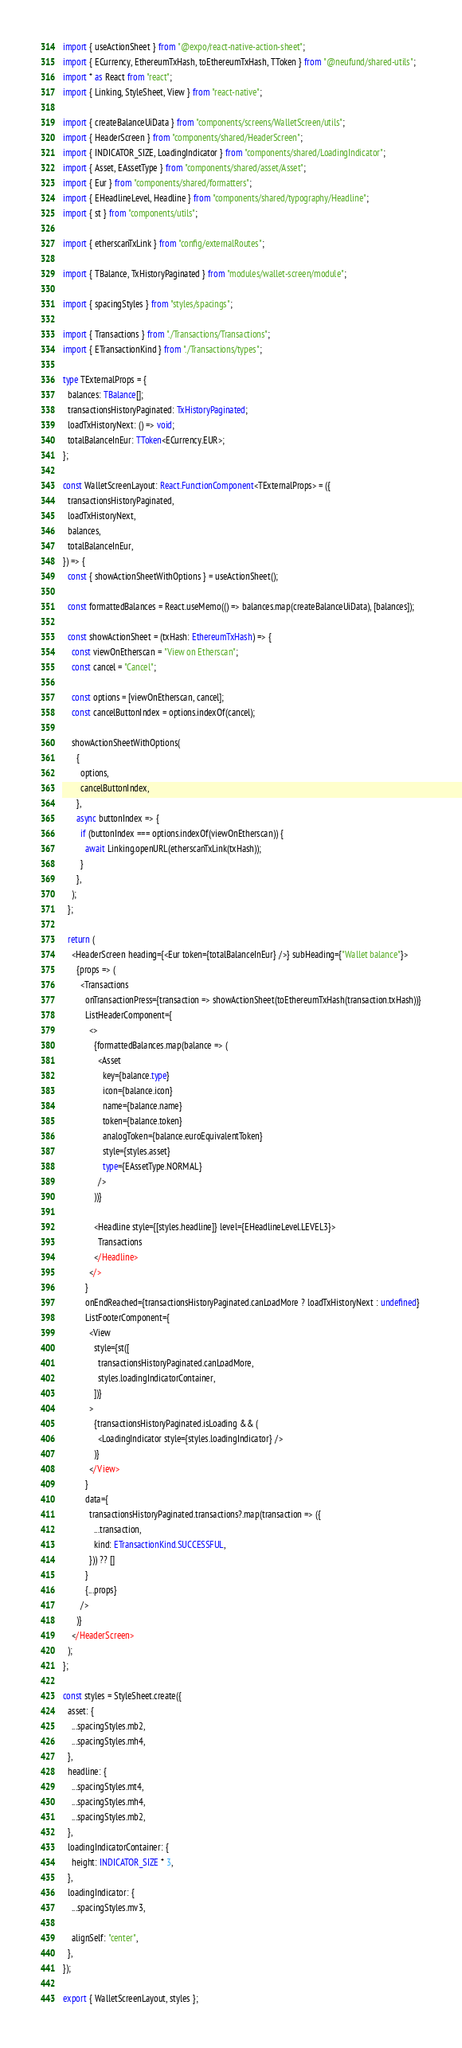Convert code to text. <code><loc_0><loc_0><loc_500><loc_500><_TypeScript_>import { useActionSheet } from "@expo/react-native-action-sheet";
import { ECurrency, EthereumTxHash, toEthereumTxHash, TToken } from "@neufund/shared-utils";
import * as React from "react";
import { Linking, StyleSheet, View } from "react-native";

import { createBalanceUiData } from "components/screens/WalletScreen/utils";
import { HeaderScreen } from "components/shared/HeaderScreen";
import { INDICATOR_SIZE, LoadingIndicator } from "components/shared/LoadingIndicator";
import { Asset, EAssetType } from "components/shared/asset/Asset";
import { Eur } from "components/shared/formatters";
import { EHeadlineLevel, Headline } from "components/shared/typography/Headline";
import { st } from "components/utils";

import { etherscanTxLink } from "config/externalRoutes";

import { TBalance, TxHistoryPaginated } from "modules/wallet-screen/module";

import { spacingStyles } from "styles/spacings";

import { Transactions } from "./Transactions/Transactions";
import { ETransactionKind } from "./Transactions/types";

type TExternalProps = {
  balances: TBalance[];
  transactionsHistoryPaginated: TxHistoryPaginated;
  loadTxHistoryNext: () => void;
  totalBalanceInEur: TToken<ECurrency.EUR>;
};

const WalletScreenLayout: React.FunctionComponent<TExternalProps> = ({
  transactionsHistoryPaginated,
  loadTxHistoryNext,
  balances,
  totalBalanceInEur,
}) => {
  const { showActionSheetWithOptions } = useActionSheet();

  const formattedBalances = React.useMemo(() => balances.map(createBalanceUiData), [balances]);

  const showActionSheet = (txHash: EthereumTxHash) => {
    const viewOnEtherscan = "View on Etherscan";
    const cancel = "Cancel";

    const options = [viewOnEtherscan, cancel];
    const cancelButtonIndex = options.indexOf(cancel);

    showActionSheetWithOptions(
      {
        options,
        cancelButtonIndex,
      },
      async buttonIndex => {
        if (buttonIndex === options.indexOf(viewOnEtherscan)) {
          await Linking.openURL(etherscanTxLink(txHash));
        }
      },
    );
  };

  return (
    <HeaderScreen heading={<Eur token={totalBalanceInEur} />} subHeading={"Wallet balance"}>
      {props => (
        <Transactions
          onTransactionPress={transaction => showActionSheet(toEthereumTxHash(transaction.txHash))}
          ListHeaderComponent={
            <>
              {formattedBalances.map(balance => (
                <Asset
                  key={balance.type}
                  icon={balance.icon}
                  name={balance.name}
                  token={balance.token}
                  analogToken={balance.euroEquivalentToken}
                  style={styles.asset}
                  type={EAssetType.NORMAL}
                />
              ))}

              <Headline style={[styles.headline]} level={EHeadlineLevel.LEVEL3}>
                Transactions
              </Headline>
            </>
          }
          onEndReached={transactionsHistoryPaginated.canLoadMore ? loadTxHistoryNext : undefined}
          ListFooterComponent={
            <View
              style={st([
                transactionsHistoryPaginated.canLoadMore,
                styles.loadingIndicatorContainer,
              ])}
            >
              {transactionsHistoryPaginated.isLoading && (
                <LoadingIndicator style={styles.loadingIndicator} />
              )}
            </View>
          }
          data={
            transactionsHistoryPaginated.transactions?.map(transaction => ({
              ...transaction,
              kind: ETransactionKind.SUCCESSFUL,
            })) ?? []
          }
          {...props}
        />
      )}
    </HeaderScreen>
  );
};

const styles = StyleSheet.create({
  asset: {
    ...spacingStyles.mb2,
    ...spacingStyles.mh4,
  },
  headline: {
    ...spacingStyles.mt4,
    ...spacingStyles.mh4,
    ...spacingStyles.mb2,
  },
  loadingIndicatorContainer: {
    height: INDICATOR_SIZE * 3,
  },
  loadingIndicator: {
    ...spacingStyles.mv3,

    alignSelf: "center",
  },
});

export { WalletScreenLayout, styles };
</code> 